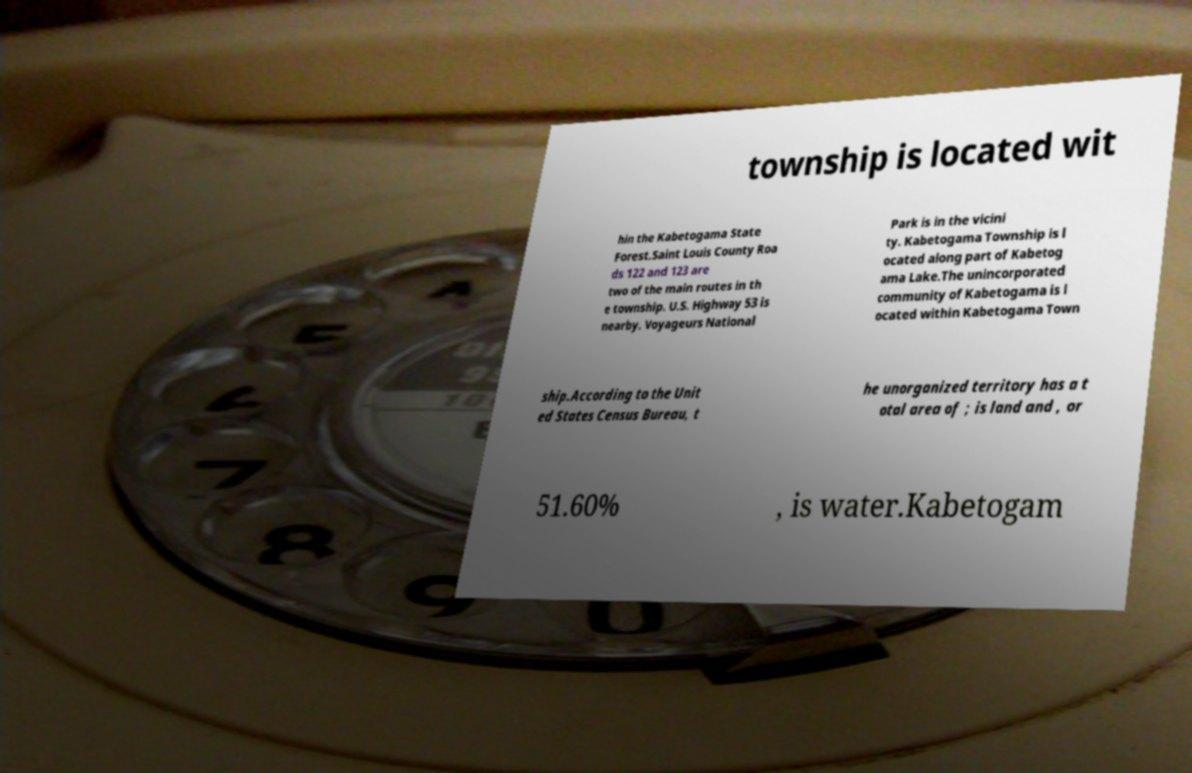Could you extract and type out the text from this image? township is located wit hin the Kabetogama State Forest.Saint Louis County Roa ds 122 and 123 are two of the main routes in th e township. U.S. Highway 53 is nearby. Voyageurs National Park is in the vicini ty. Kabetogama Township is l ocated along part of Kabetog ama Lake.The unincorporated community of Kabetogama is l ocated within Kabetogama Town ship.According to the Unit ed States Census Bureau, t he unorganized territory has a t otal area of ; is land and , or 51.60% , is water.Kabetogam 